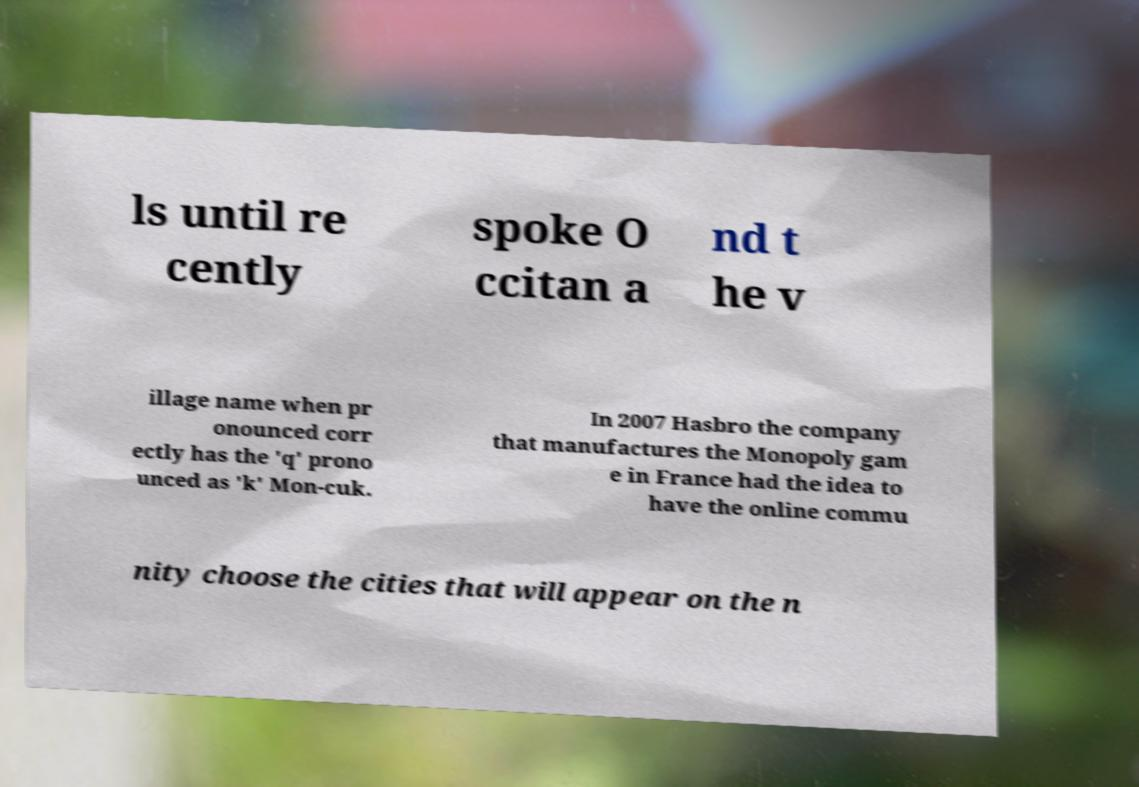Please read and relay the text visible in this image. What does it say? ls until re cently spoke O ccitan a nd t he v illage name when pr onounced corr ectly has the 'q' prono unced as 'k' Mon-cuk. In 2007 Hasbro the company that manufactures the Monopoly gam e in France had the idea to have the online commu nity choose the cities that will appear on the n 